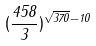<formula> <loc_0><loc_0><loc_500><loc_500>( \frac { 4 5 8 } { 3 } ) ^ { \sqrt { 3 7 0 } - 1 0 }</formula> 